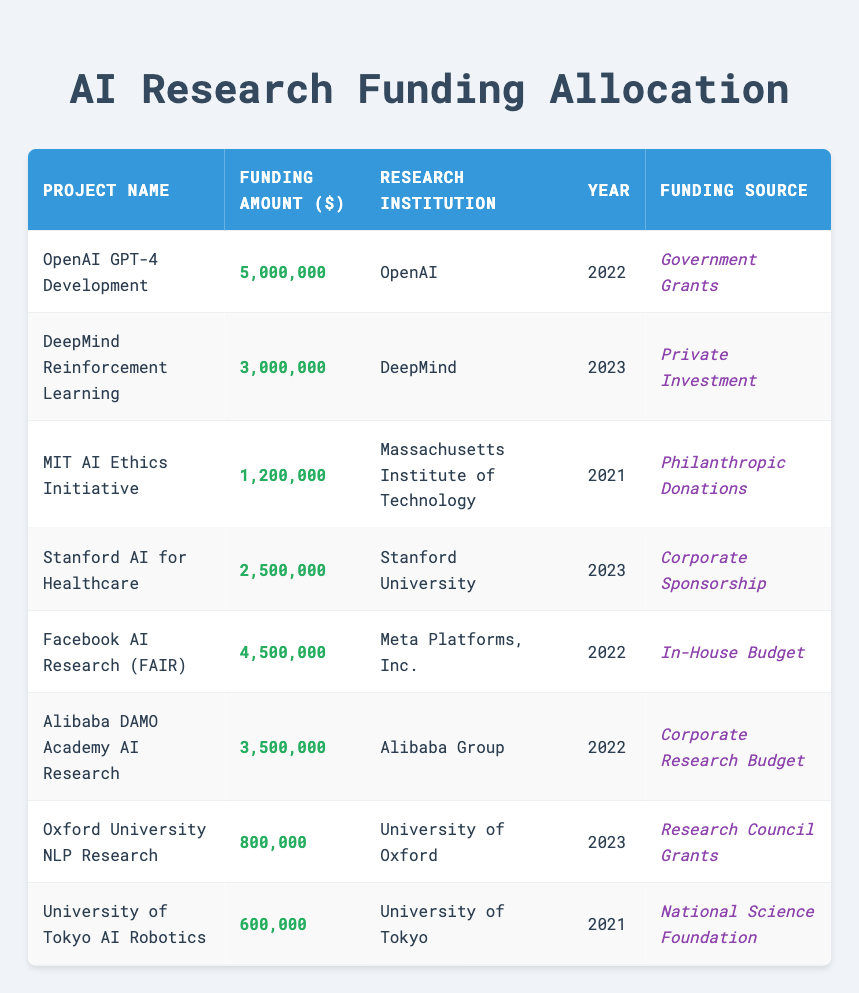What is the total funding amount allocated to AI projects in 2022? The projects that received funding in 2022 are OpenAI GPT-4 Development ($5,000,000), Facebook AI Research (FAIR) ($4,500,000), Alibaba DAMO Academy AI Research ($3,500,000). Adding these amounts gives $5,000,000 + $4,500,000 + $3,500,000 = $13,000,000.
Answer: 13,000,000 Which project received the least funding and what was the amount? The project with the least funding is Oxford University NLP Research, which received $800,000. This can be found by comparing the funding amounts listed for all projects.
Answer: Oxford University NLP Research, 800,000 Is there any project that received funding from both Government Grants and Private Investment? No, there is no project that received funding from both sources as each funding source is unique to a project in this table. Each project has only one funding source listed.
Answer: No What is the average funding amount for projects in 2023? The projects funded in 2023 are DeepMind Reinforcement Learning ($3,000,000) and Stanford AI for Healthcare ($2,500,000). The sum is $3,000,000 + $2,500,000 = $5,500,000, and there are 2 projects, so the average is $5,500,000 / 2 = $2,750,000.
Answer: 2,750,000 Did the Massachusetts Institute of Technology receive more funding than the University of Tokyo? Yes, the Massachusetts Institute of Technology received $1,200,000 for the AI Ethics Initiative, whereas the University of Tokyo received $600,000 for AI Robotics. Therefore, MIT received more funding.
Answer: Yes Which research institution received the highest total funding amount across all its projects? OpenAI received the highest funding amount of $5,000,000 for the GPT-4 Development project, which is more than any funding amounts for projects from other institutions listed in the table.
Answer: OpenAI, 5,000,000 How many projects received funding from Corporate Sponsorship? There is one project that received funding from Corporate Sponsorship, which is Stanford AI for Healthcare. This information is seen distinctly in the funding source column.
Answer: 1 What is the difference in funding amounts between the two projects with the highest funding? The two highest funding amounts are OpenAI GPT-4 Development ($5,000,000) and Facebook AI Research (FAIR) ($4,500,000). The difference is $5,000,000 - $4,500,000 = $500,000.
Answer: 500,000 